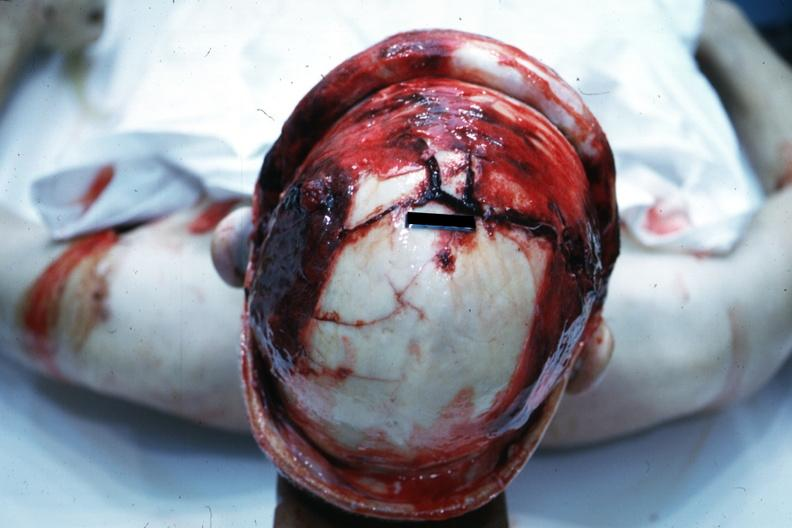does this image show view of head with scalp retracted to show massive fractures?
Answer the question using a single word or phrase. Yes 